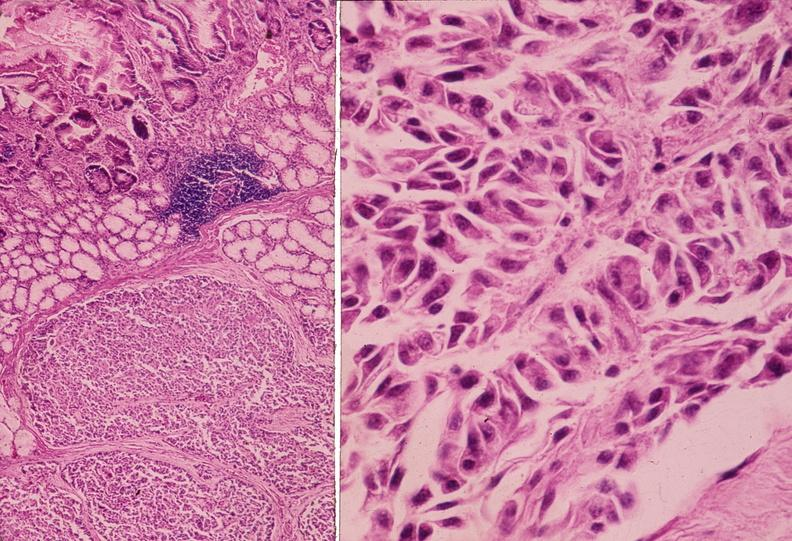does this image show islet cell tumor, zollinger ellison syndrome?
Answer the question using a single word or phrase. Yes 